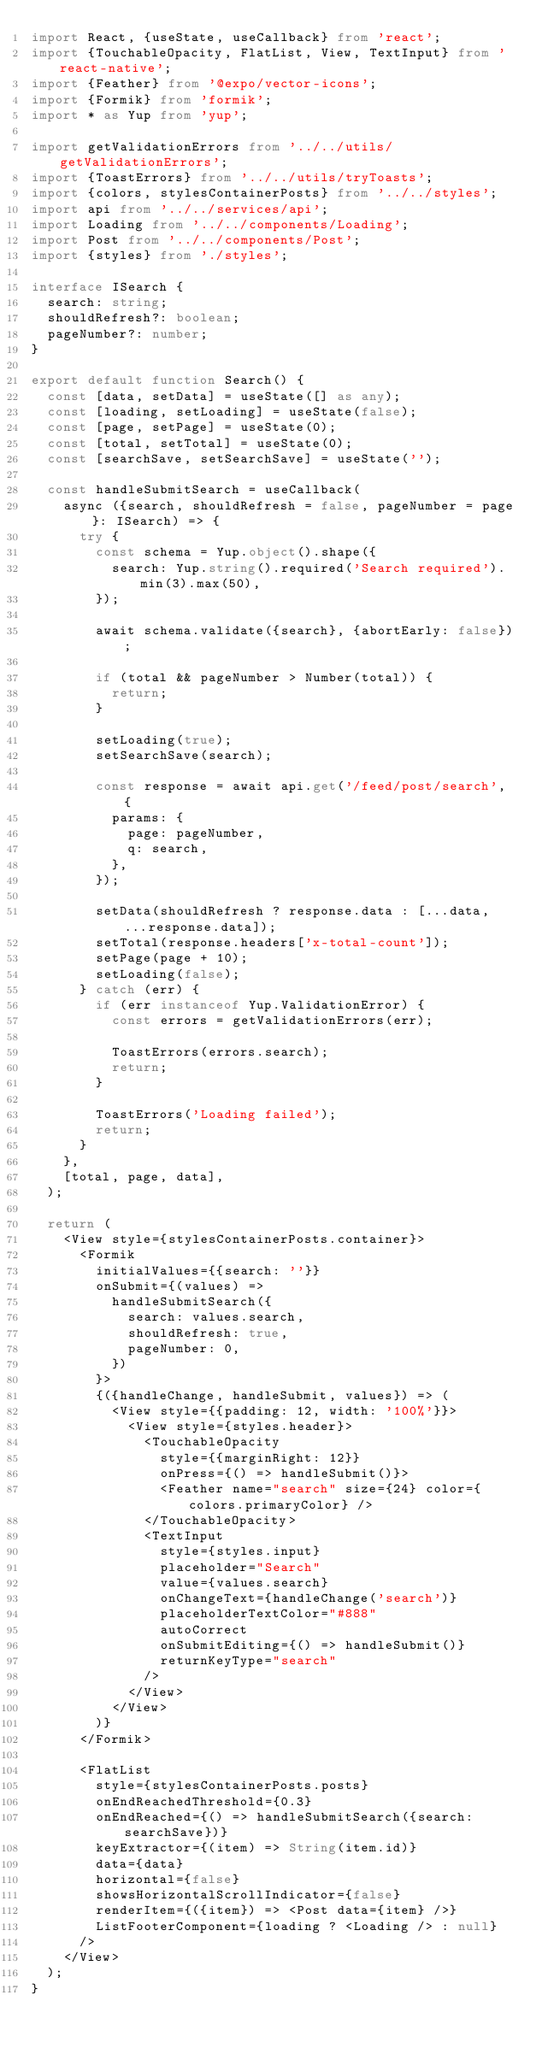<code> <loc_0><loc_0><loc_500><loc_500><_TypeScript_>import React, {useState, useCallback} from 'react';
import {TouchableOpacity, FlatList, View, TextInput} from 'react-native';
import {Feather} from '@expo/vector-icons';
import {Formik} from 'formik';
import * as Yup from 'yup';

import getValidationErrors from '../../utils/getValidationErrors';
import {ToastErrors} from '../../utils/tryToasts';
import {colors, stylesContainerPosts} from '../../styles';
import api from '../../services/api';
import Loading from '../../components/Loading';
import Post from '../../components/Post';
import {styles} from './styles';

interface ISearch {
  search: string;
  shouldRefresh?: boolean;
  pageNumber?: number;
}

export default function Search() {
  const [data, setData] = useState([] as any);
  const [loading, setLoading] = useState(false);
  const [page, setPage] = useState(0);
  const [total, setTotal] = useState(0);
  const [searchSave, setSearchSave] = useState('');

  const handleSubmitSearch = useCallback(
    async ({search, shouldRefresh = false, pageNumber = page}: ISearch) => {
      try {
        const schema = Yup.object().shape({
          search: Yup.string().required('Search required').min(3).max(50),
        });

        await schema.validate({search}, {abortEarly: false});

        if (total && pageNumber > Number(total)) {
          return;
        }

        setLoading(true);
        setSearchSave(search);

        const response = await api.get('/feed/post/search', {
          params: {
            page: pageNumber,
            q: search,
          },
        });

        setData(shouldRefresh ? response.data : [...data, ...response.data]);
        setTotal(response.headers['x-total-count']);
        setPage(page + 10);
        setLoading(false);
      } catch (err) {
        if (err instanceof Yup.ValidationError) {
          const errors = getValidationErrors(err);

          ToastErrors(errors.search);
          return;
        }

        ToastErrors('Loading failed');
        return;
      }
    },
    [total, page, data],
  );

  return (
    <View style={stylesContainerPosts.container}>
      <Formik
        initialValues={{search: ''}}
        onSubmit={(values) =>
          handleSubmitSearch({
            search: values.search,
            shouldRefresh: true,
            pageNumber: 0,
          })
        }>
        {({handleChange, handleSubmit, values}) => (
          <View style={{padding: 12, width: '100%'}}>
            <View style={styles.header}>
              <TouchableOpacity
                style={{marginRight: 12}}
                onPress={() => handleSubmit()}>
                <Feather name="search" size={24} color={colors.primaryColor} />
              </TouchableOpacity>
              <TextInput
                style={styles.input}
                placeholder="Search"
                value={values.search}
                onChangeText={handleChange('search')}
                placeholderTextColor="#888"
                autoCorrect
                onSubmitEditing={() => handleSubmit()}
                returnKeyType="search"
              />
            </View>
          </View>
        )}
      </Formik>

      <FlatList
        style={stylesContainerPosts.posts}
        onEndReachedThreshold={0.3}
        onEndReached={() => handleSubmitSearch({search: searchSave})}
        keyExtractor={(item) => String(item.id)}
        data={data}
        horizontal={false}
        showsHorizontalScrollIndicator={false}
        renderItem={({item}) => <Post data={item} />}
        ListFooterComponent={loading ? <Loading /> : null}
      />
    </View>
  );
}
</code> 